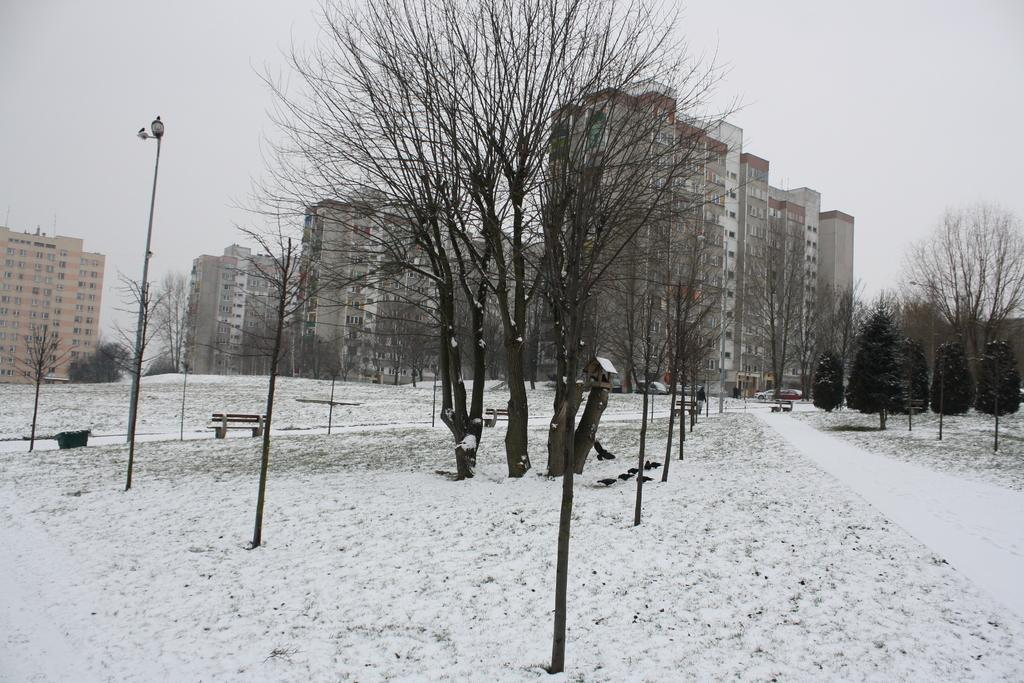What type of vegetation can be seen in the image? There are trees in the image. What type of artificial lighting is present in the image? There are street lights in the image. What type of structures can be seen in the image? There are poles in the image. What type of pathways are available for walking in the image? There are walkways in the image. What type of seating is available in the image? There are benches in the image. What type of weather condition is depicted in the image? There is snow in the image. What type of animals can be seen in the image? There are birds in the image. What type of bread can be seen in the image? There is no bread present in the image. What type of news can be seen on the benches in the image? There is no news present in the image; it only shows trees, street lights, poles, walkways, benches, snow, birds, and the background elements. 